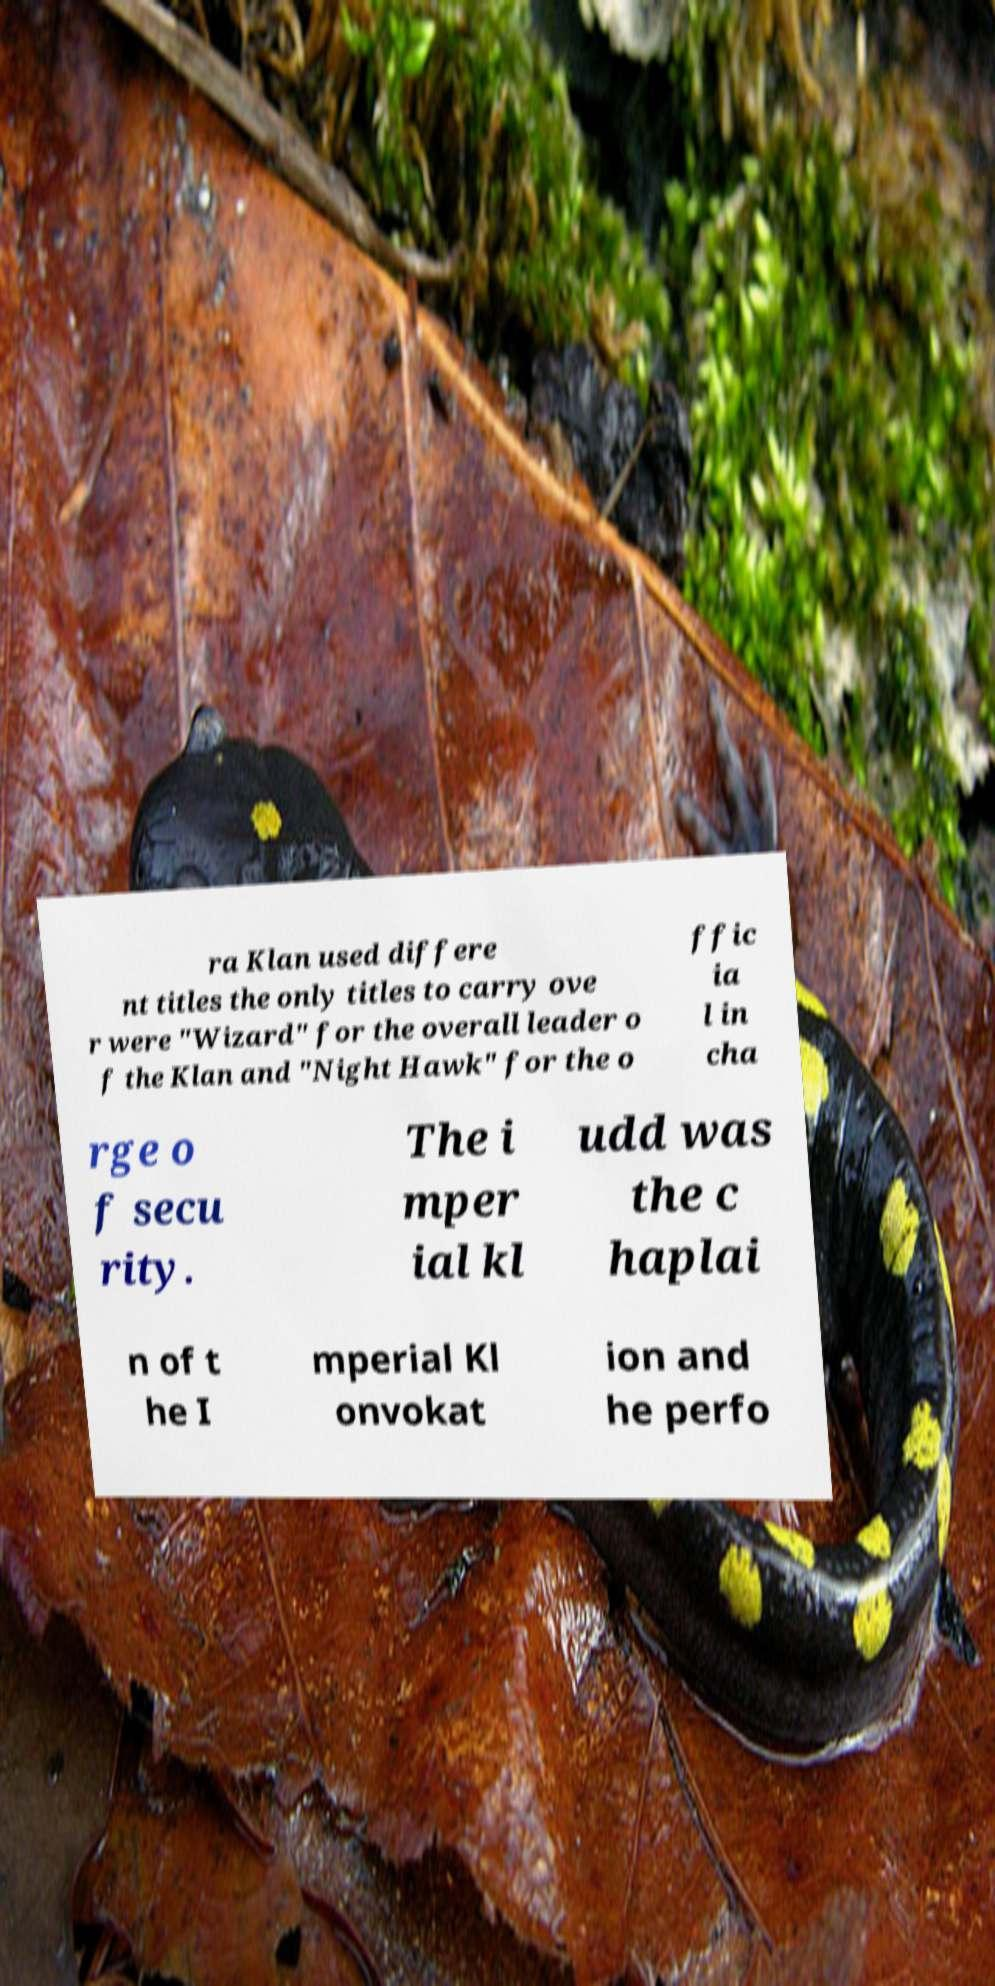Please identify and transcribe the text found in this image. ra Klan used differe nt titles the only titles to carry ove r were "Wizard" for the overall leader o f the Klan and "Night Hawk" for the o ffic ia l in cha rge o f secu rity. The i mper ial kl udd was the c haplai n of t he I mperial Kl onvokat ion and he perfo 